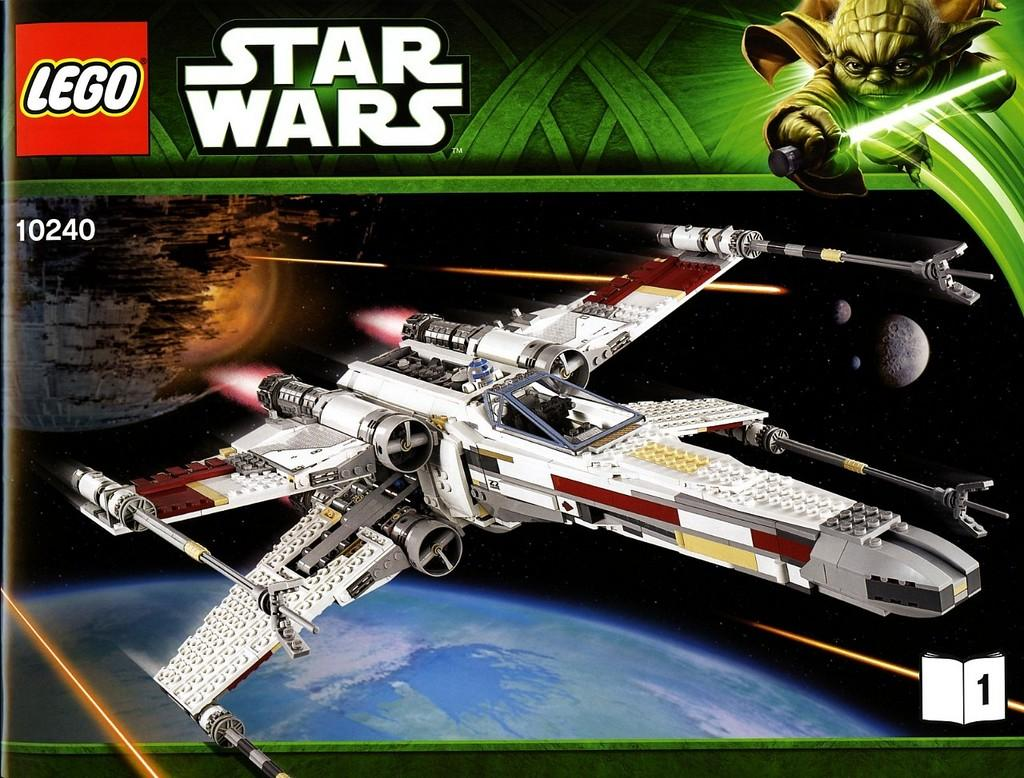What type of editing has been done to the image? The image is edited, but the specific type of editing is not mentioned in the facts. What is the main subject of the image? There is a plane in the image. What else can be seen around the plane? There are images and logos around the plane. What text is written above the image? The text "STAR WARS" is written above the image. What type of toothpaste is being advertised in the image? There is no toothpaste present in the image. How many sticks are visible in the image? There are no sticks visible in the image. 